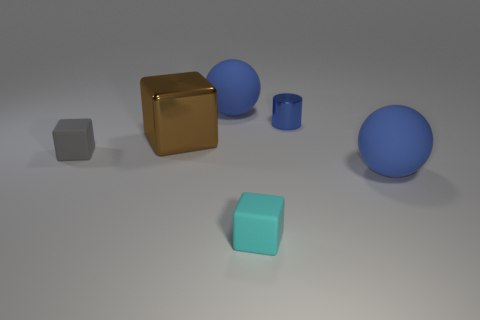Add 2 blue balls. How many objects exist? 8 Subtract all cylinders. How many objects are left? 5 Subtract all big metal things. Subtract all large shiny blocks. How many objects are left? 4 Add 4 blue objects. How many blue objects are left? 7 Add 2 tiny blue objects. How many tiny blue objects exist? 3 Subtract 0 green cylinders. How many objects are left? 6 